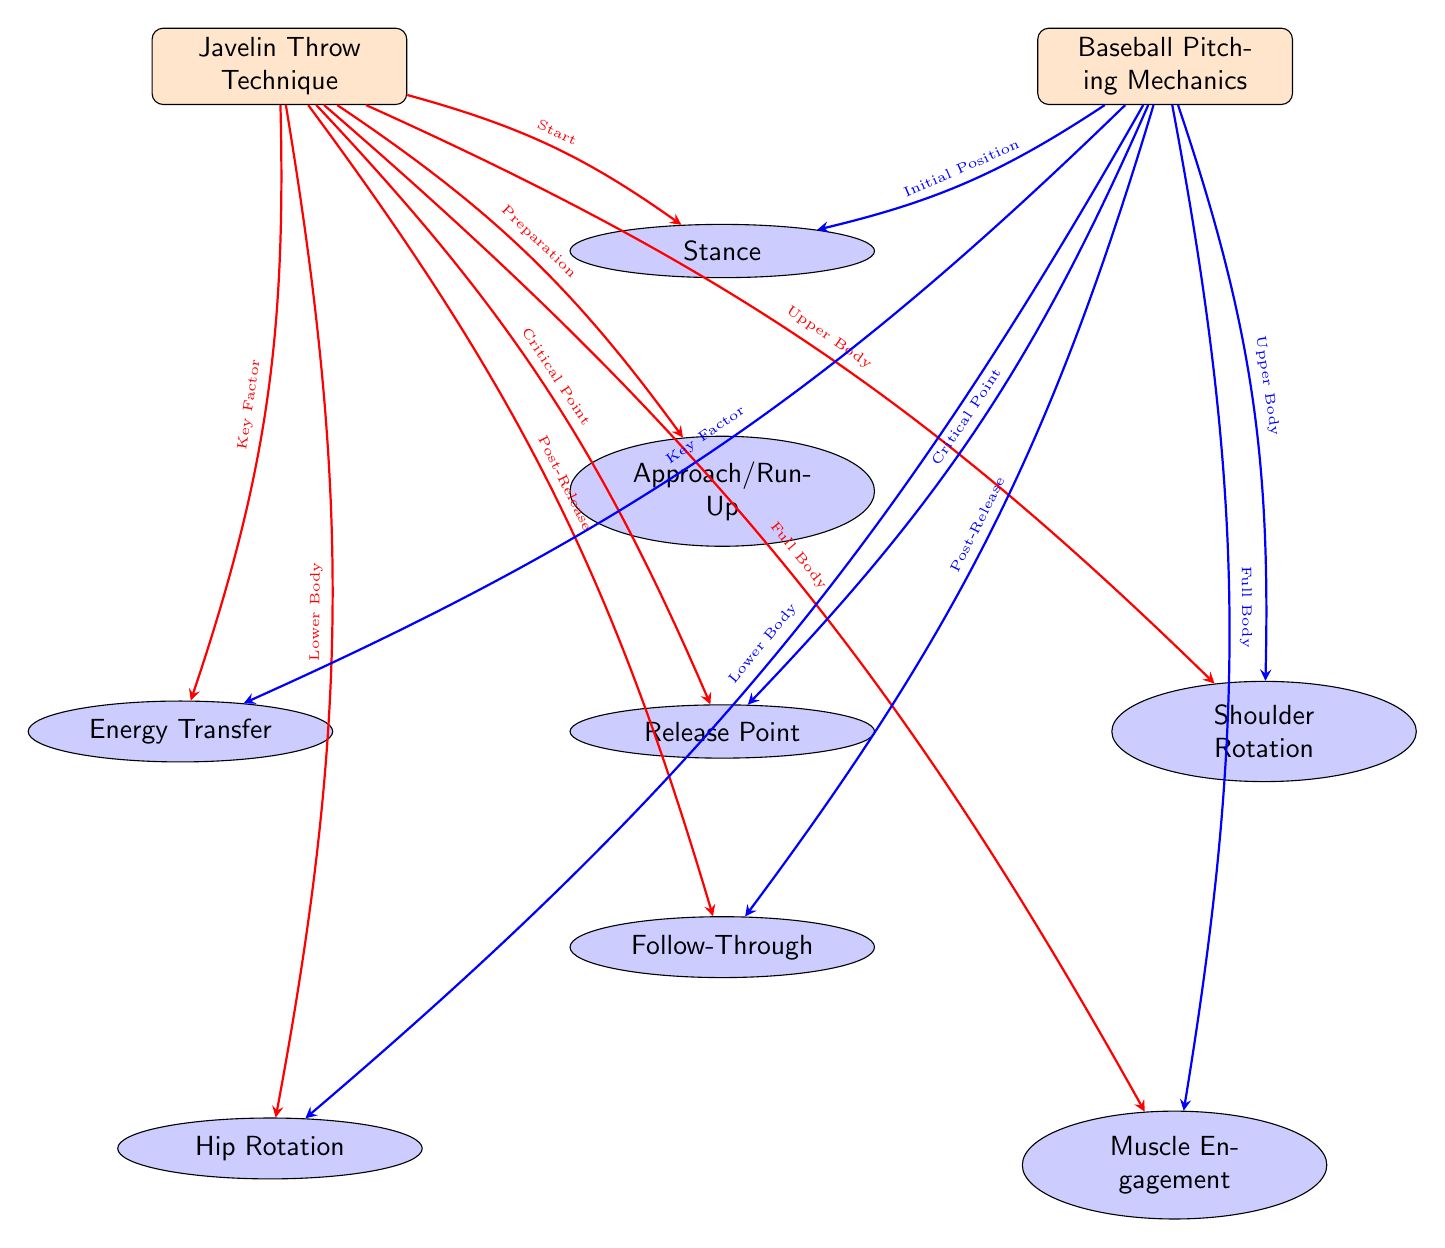What are the two sports compared in the diagram? The diagram explicitly labels two sports: "Javelin Throw Technique" on the left and "Baseball Pitching Mechanics" on the right. This is the primary focus of the diagram to contrast the mechanics involved.
Answer: Javelin Throw Technique, Baseball Pitching Mechanics How many aspects are listed under both sports? The diagram shows a total of eight aspects that are connected to both sports (stance, approach/run-up, release point, follow-through, energy transfer, shoulder rotation, hip rotation, muscle engagement). Counting each one verifies this information.
Answer: 8 What is the critical point aspect for both sports? Both sports label "Release Point" as the critical point. Looking at the arrows connecting each sport to this particular aspect confirms this terminology.
Answer: Release Point Which aspect is positioned below the energy transfer node for baseball? The diagram indicates "Hip Rotation" is below the "Energy Transfer" node for baseball. Tracing the connections from the baseball node to the energy transfer and then downwards leads directly to hip rotation.
Answer: Hip Rotation What type of body engagement is indicated for both javelin and baseball mechanics? Both javelin throw and baseball pitching are described as utilizing "Full Body" engagement, as is shown by the arrows leading to the muscle engagement node, which distinctly describes involvement of the entire body for both sports.
Answer: Full Body 